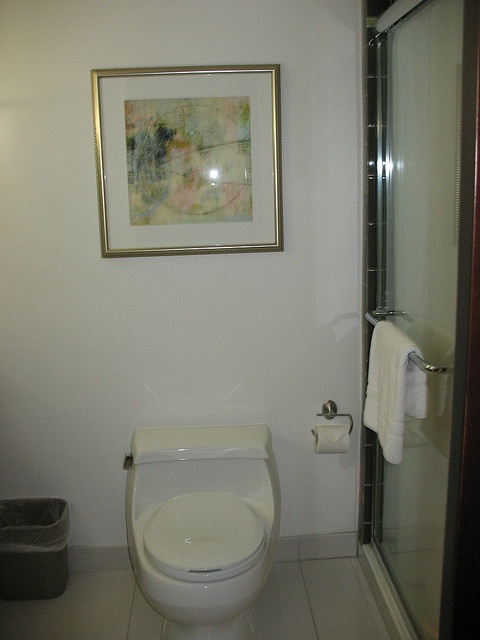Describe the objects in this image and their specific colors. I can see a toilet in gray tones in this image. 